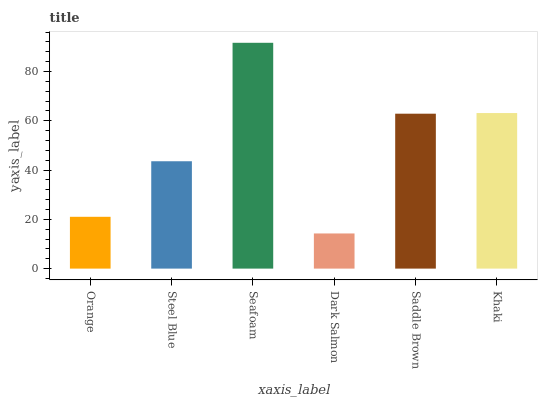Is Dark Salmon the minimum?
Answer yes or no. Yes. Is Seafoam the maximum?
Answer yes or no. Yes. Is Steel Blue the minimum?
Answer yes or no. No. Is Steel Blue the maximum?
Answer yes or no. No. Is Steel Blue greater than Orange?
Answer yes or no. Yes. Is Orange less than Steel Blue?
Answer yes or no. Yes. Is Orange greater than Steel Blue?
Answer yes or no. No. Is Steel Blue less than Orange?
Answer yes or no. No. Is Saddle Brown the high median?
Answer yes or no. Yes. Is Steel Blue the low median?
Answer yes or no. Yes. Is Dark Salmon the high median?
Answer yes or no. No. Is Saddle Brown the low median?
Answer yes or no. No. 